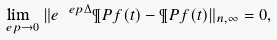Convert formula to latex. <formula><loc_0><loc_0><loc_500><loc_500>\lim _ { \ e p \to 0 } \| e ^ { \ e p \Delta } \P P f ( t ) - \P P f ( t ) \| _ { n , \infty } = 0 ,</formula> 